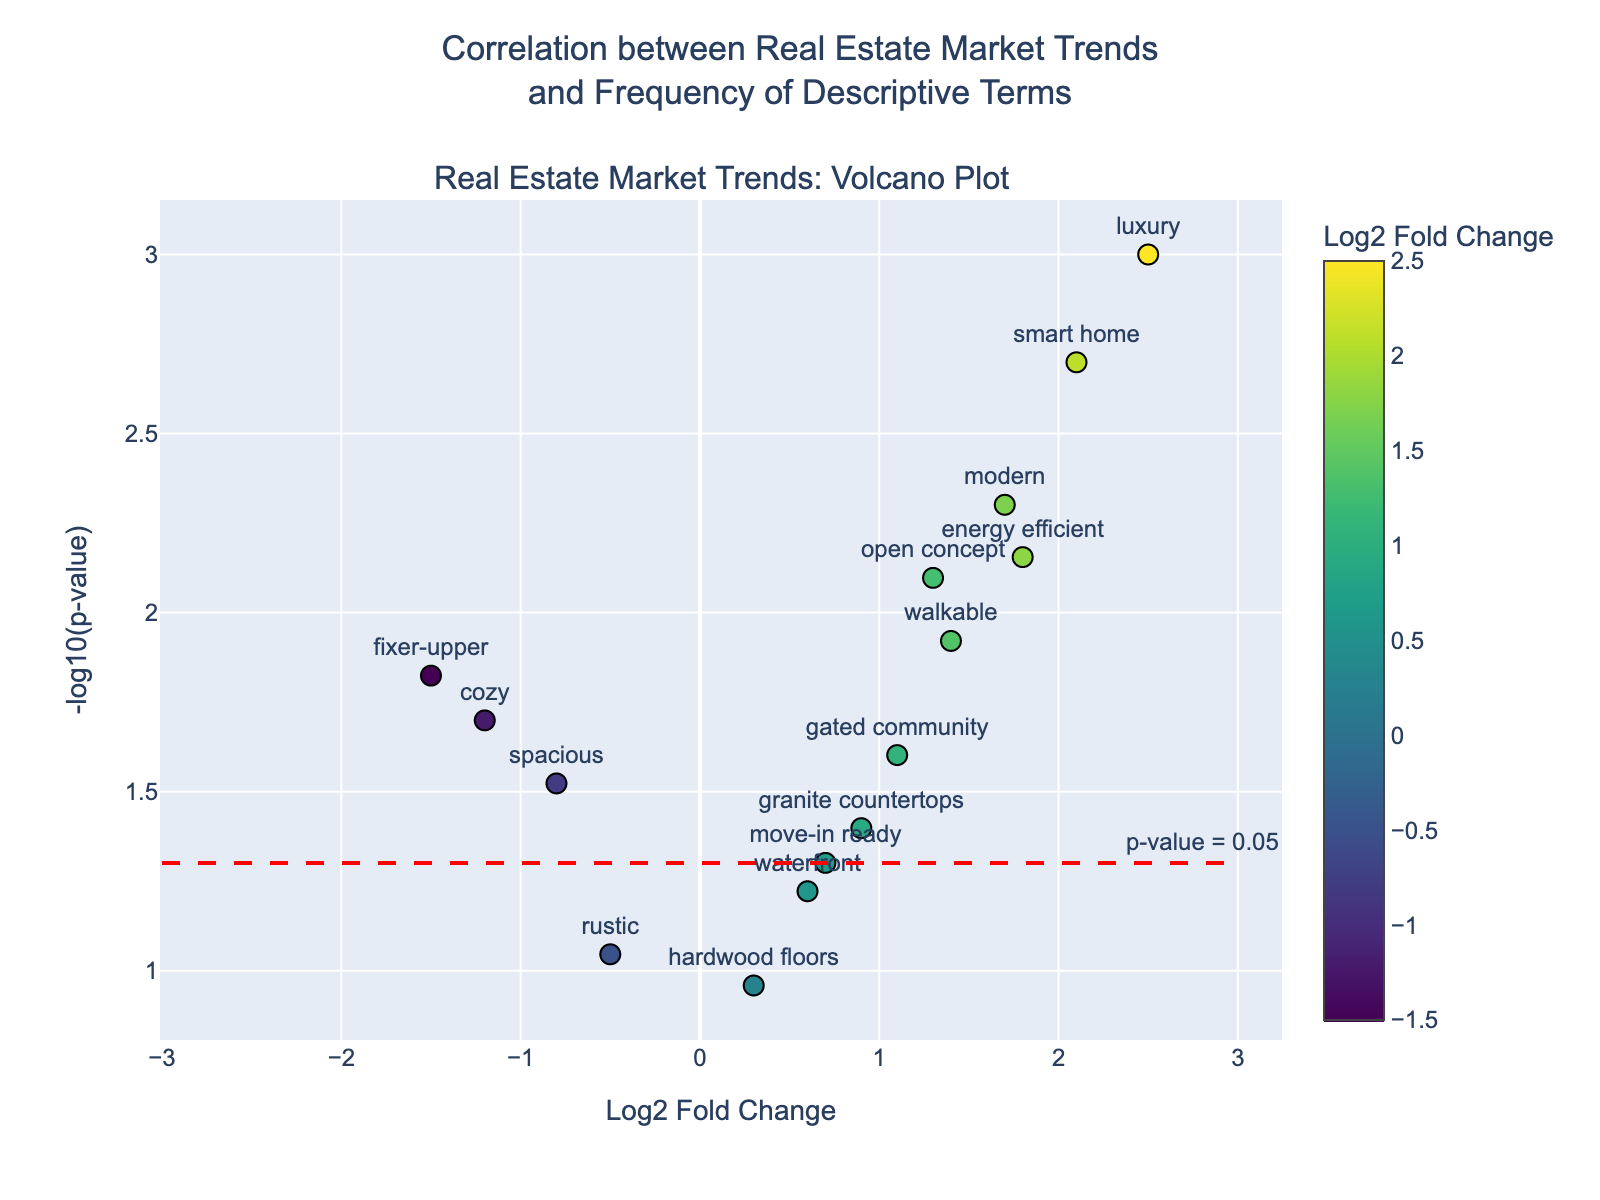What is the title of the plot? The title is positioned at the top center of the plot. It reads "Correlation between Real Estate Market Trends and Frequency of Descriptive Terms".
Answer: "Correlation between Real Estate Market Trends and Frequency of Descriptive Terms" Which term has the highest log2 fold change? Look for the term with the highest value on the x-axis. The term "luxury" appears furthest to the right.
Answer: "luxury" What does a red dashed line represent in the plot? The red dashed line is horizontal and represents the significance threshold for the p-value. The annotation next to it reads "p-value = 0.05", indicating this line marks where the p-value equals 0.05.
Answer: significance threshold for p-value How many terms have a p-value below 0.05? Count the number of points above the red dashed line (since higher -log10(p-value) means a lower p-value). There are 10 points above this line.
Answer: 10 Which term is closest to the significance threshold line? Identify the point closest to the red dashed line. The term "move-in ready" is the closest to this line.
Answer: "move-in ready" Which term has the smallest p-value? The smallest p-value corresponds to the highest -log10(p-value). The term "luxury" has the highest y-coordinate, indicating the smallest p-value.
Answer: "luxury" Which term has the largest negative log2 fold change? Look for the term furthest to the left on the x-axis. The term "fixer-upper" has the largest negative log2 fold change.
Answer: "fixer-upper" What is the log2 fold change for the term "granite countertops"? Locate the term "granite countertops" on the plot. Its x-coordinate indicates the log2 fold change, which is approximately 0.9.
Answer: 0.9 Which term has the highest positive log2 fold change other than "luxury"? Exclude "luxury" and find the term with the next highest value on the x-axis. The term "smart home" has the next highest positive log2 fold change.
Answer: "smart home" How does the term "rustic" compare to others in terms of significance? Find "rustic" on the plot and note its y-coordinate to compare its significance based on p-value. It is positioned below the red dashed line, indicating it is less significant with a p-value above 0.05.
Answer: less significant 